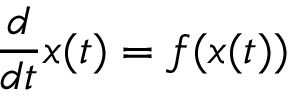Convert formula to latex. <formula><loc_0><loc_0><loc_500><loc_500>{ \frac { d } { d t } } x ( t ) = f ( x ( t ) )</formula> 